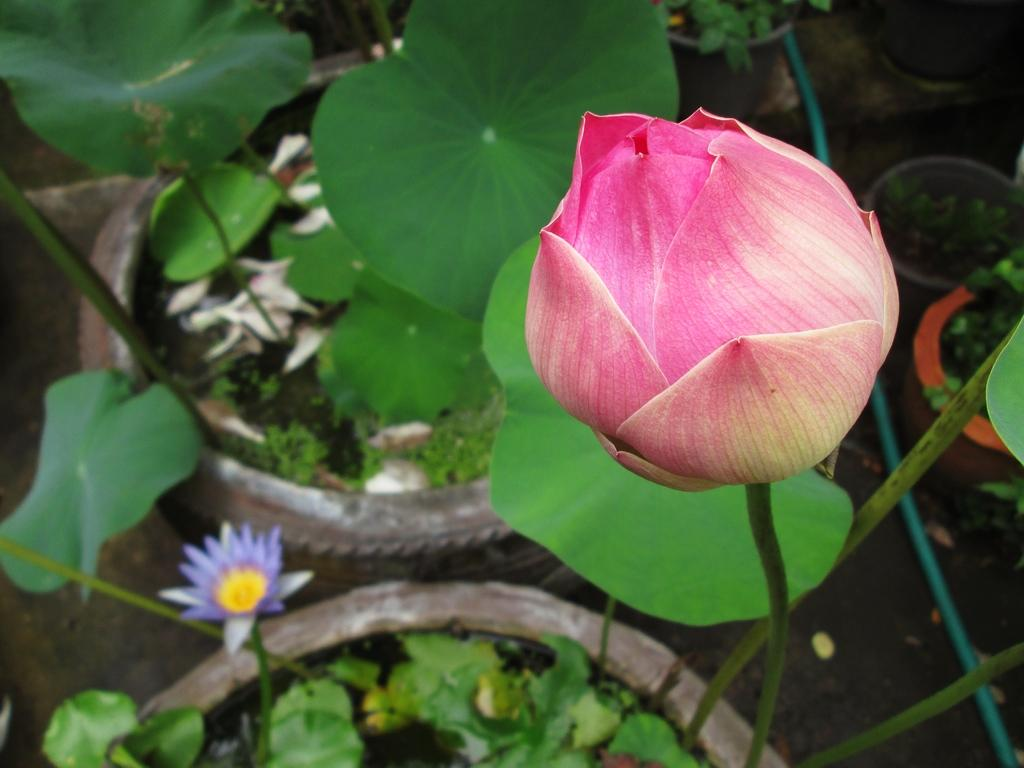How many flowers are present in the image? There are two flowers in the image. What else can be seen in the image besides the flowers? Plants are visible behind the flowers in the image. How many girls are riding the horse on the waves in the image? There are no girls, horses, or waves present in the image; it only features two flowers and plants. 